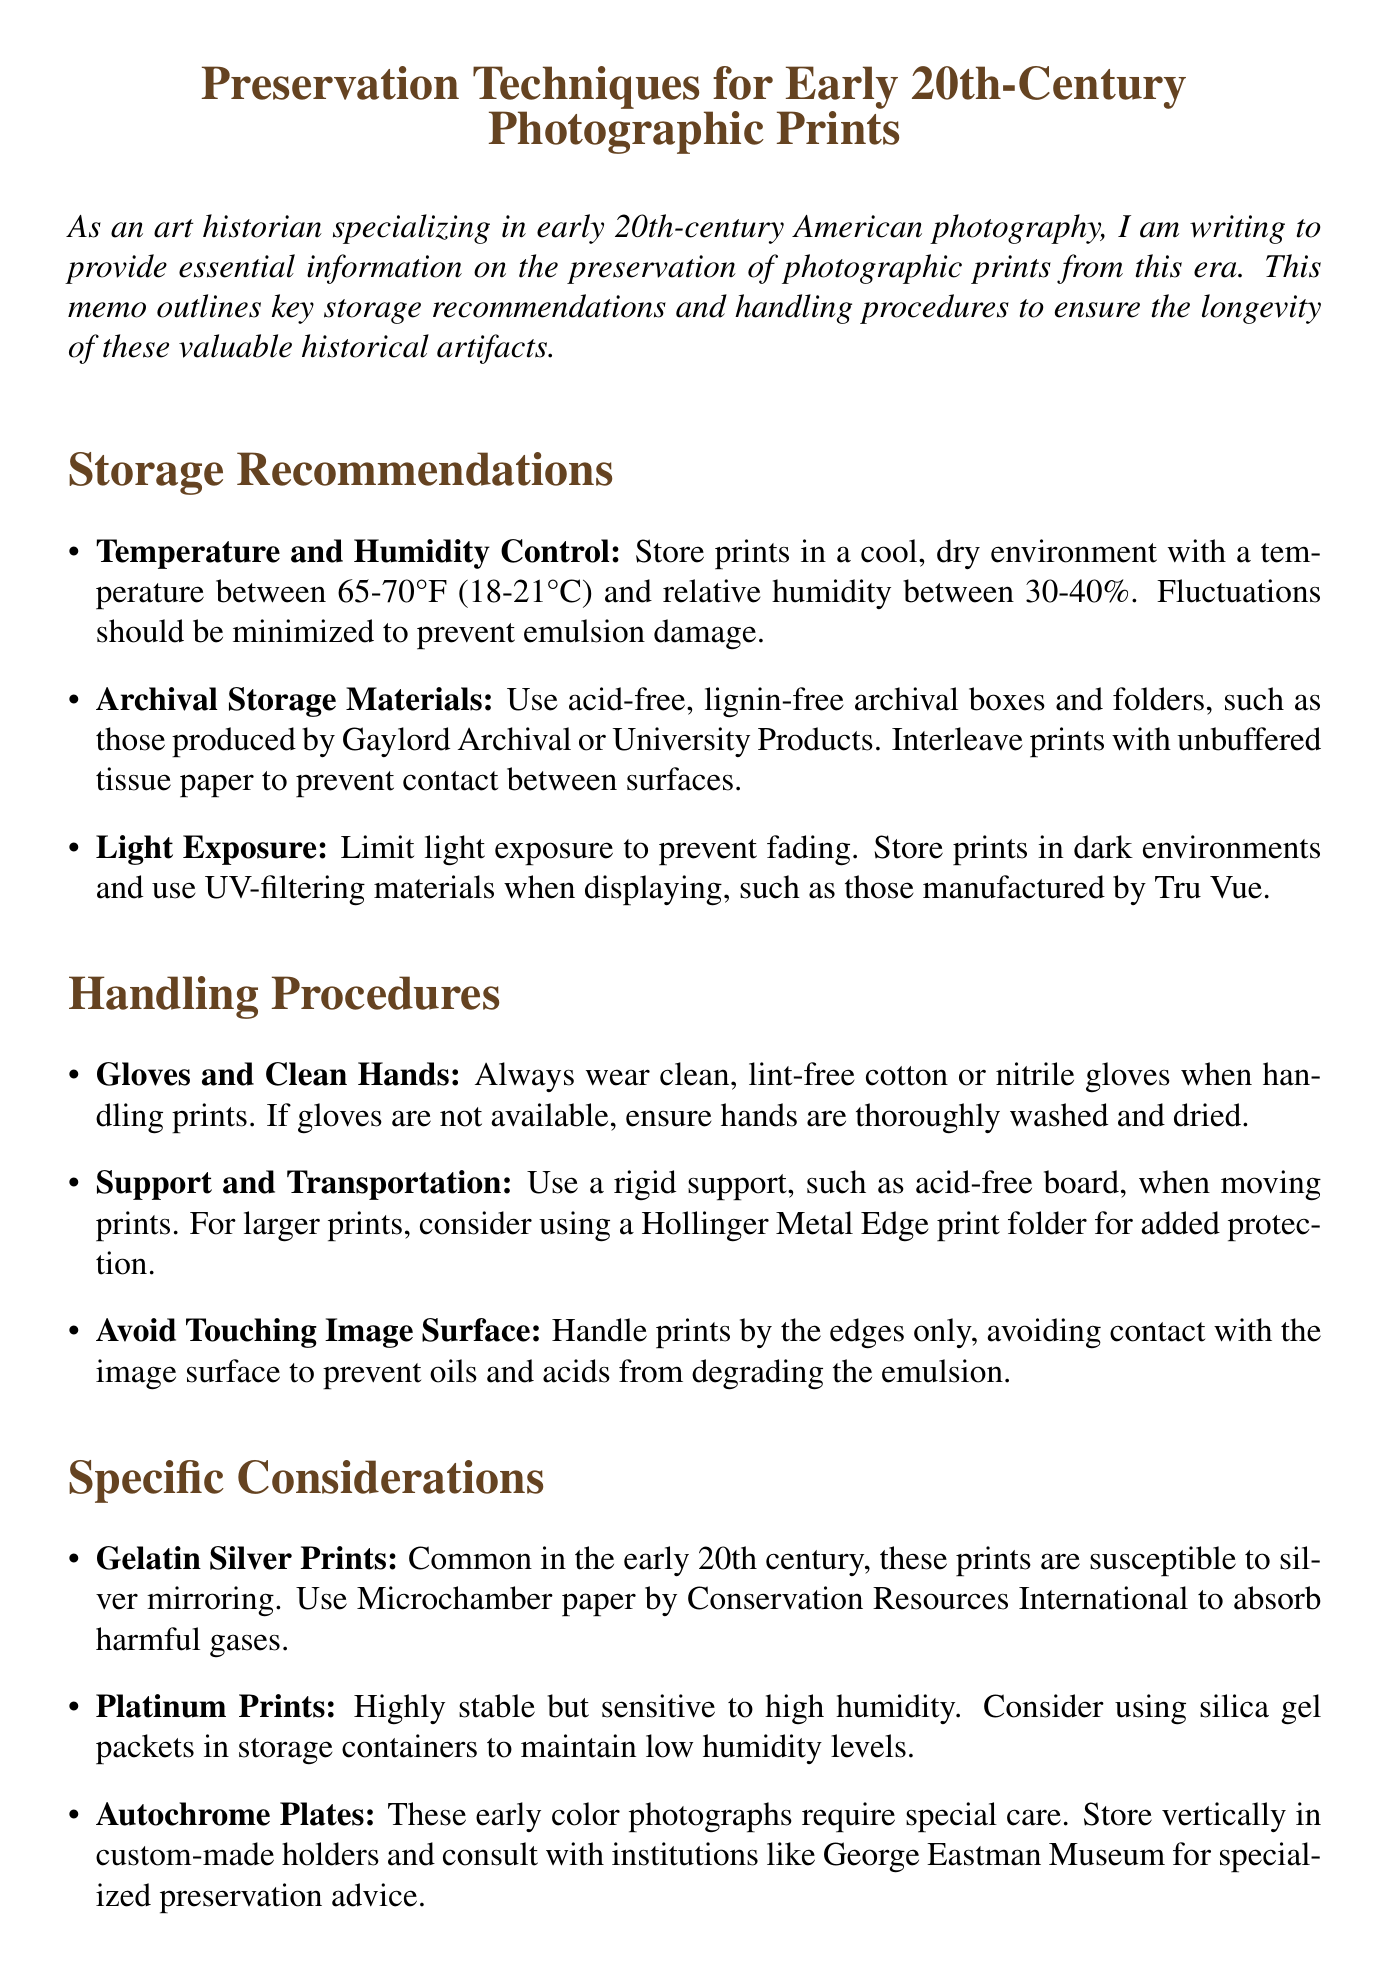What is the recommended storage temperature range for prints? The recommended storage temperature range is specified as between 65-70°F (18-21°C).
Answer: 65-70°F (18-21°C) What type of gloves should be worn when handling prints? The memo specifies to wear clean, lint-free cotton or nitrile gloves.
Answer: Cotton or nitrile What is a specific preservation technique for gelatin silver prints? The memo states to use Microchamber paper to absorb harmful gases for gelatin silver prints.
Answer: Microchamber paper How should prints be stored to limit light exposure? Prints should be stored in dark environments to limit light exposure.
Answer: Dark environments What is the relative humidity range recommended for storage? The recommended relative humidity range for storage is between 30-40%.
Answer: 30-40% Which archival materials are recommended for storage? Acid-free, lignin-free archival boxes and folders are recommended for storage.
Answer: Acid-free, lignin-free archival boxes What should be used to support larger prints during transportation? The memo recommends using a Hollinger Metal Edge print folder for larger prints.
Answer: Hollinger Metal Edge print folder How should autochrome plates be stored? The memo advises storing autochrome plates vertically in custom-made holders.
Answer: Vertically in custom-made holders 